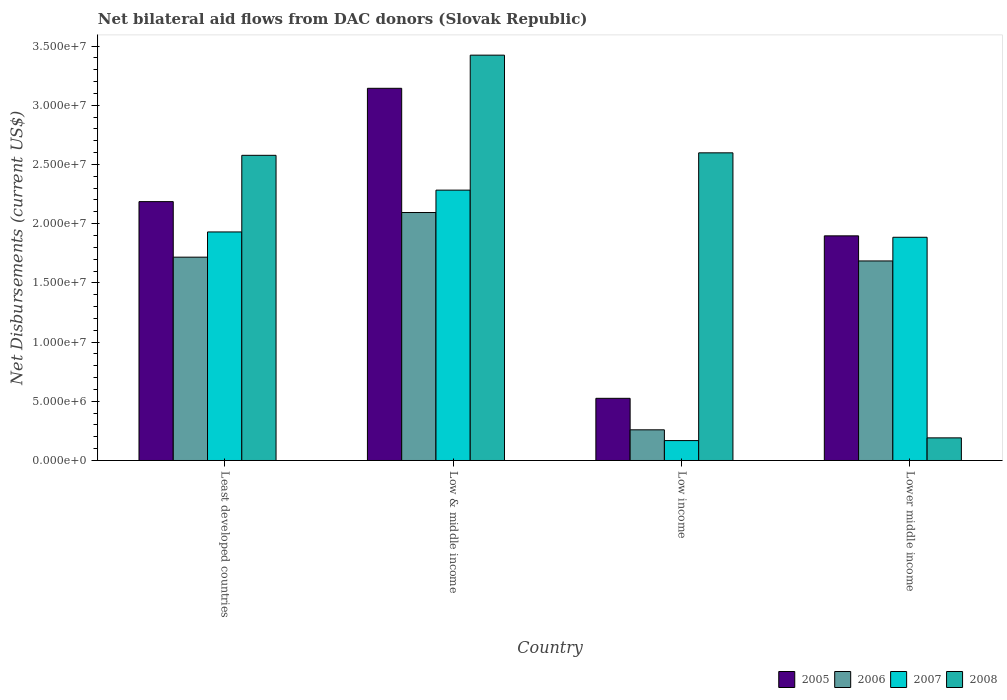How many different coloured bars are there?
Your response must be concise. 4. How many groups of bars are there?
Provide a succinct answer. 4. Are the number of bars per tick equal to the number of legend labels?
Make the answer very short. Yes. Are the number of bars on each tick of the X-axis equal?
Offer a terse response. Yes. How many bars are there on the 1st tick from the right?
Give a very brief answer. 4. What is the label of the 4th group of bars from the left?
Your response must be concise. Lower middle income. What is the net bilateral aid flows in 2006 in Low income?
Your answer should be compact. 2.59e+06. Across all countries, what is the maximum net bilateral aid flows in 2008?
Offer a terse response. 3.42e+07. Across all countries, what is the minimum net bilateral aid flows in 2005?
Provide a succinct answer. 5.25e+06. In which country was the net bilateral aid flows in 2007 maximum?
Your response must be concise. Low & middle income. What is the total net bilateral aid flows in 2007 in the graph?
Keep it short and to the point. 6.27e+07. What is the difference between the net bilateral aid flows in 2005 in Least developed countries and that in Lower middle income?
Provide a short and direct response. 2.89e+06. What is the difference between the net bilateral aid flows in 2005 in Lower middle income and the net bilateral aid flows in 2007 in Low & middle income?
Provide a succinct answer. -3.86e+06. What is the average net bilateral aid flows in 2006 per country?
Ensure brevity in your answer.  1.44e+07. What is the difference between the net bilateral aid flows of/in 2008 and net bilateral aid flows of/in 2006 in Lower middle income?
Give a very brief answer. -1.49e+07. What is the ratio of the net bilateral aid flows in 2007 in Least developed countries to that in Low & middle income?
Make the answer very short. 0.85. What is the difference between the highest and the second highest net bilateral aid flows in 2007?
Keep it short and to the point. 3.53e+06. What is the difference between the highest and the lowest net bilateral aid flows in 2006?
Keep it short and to the point. 1.84e+07. Is the sum of the net bilateral aid flows in 2007 in Low income and Lower middle income greater than the maximum net bilateral aid flows in 2006 across all countries?
Offer a terse response. No. What does the 1st bar from the left in Low & middle income represents?
Your answer should be very brief. 2005. What does the 1st bar from the right in Low income represents?
Offer a very short reply. 2008. Is it the case that in every country, the sum of the net bilateral aid flows in 2007 and net bilateral aid flows in 2006 is greater than the net bilateral aid flows in 2005?
Your response must be concise. No. How many bars are there?
Your answer should be compact. 16. Are all the bars in the graph horizontal?
Provide a short and direct response. No. What is the difference between two consecutive major ticks on the Y-axis?
Your answer should be very brief. 5.00e+06. Are the values on the major ticks of Y-axis written in scientific E-notation?
Your answer should be very brief. Yes. Does the graph contain any zero values?
Provide a short and direct response. No. Where does the legend appear in the graph?
Offer a very short reply. Bottom right. What is the title of the graph?
Offer a terse response. Net bilateral aid flows from DAC donors (Slovak Republic). Does "2008" appear as one of the legend labels in the graph?
Provide a succinct answer. Yes. What is the label or title of the Y-axis?
Keep it short and to the point. Net Disbursements (current US$). What is the Net Disbursements (current US$) in 2005 in Least developed countries?
Offer a terse response. 2.19e+07. What is the Net Disbursements (current US$) of 2006 in Least developed countries?
Offer a very short reply. 1.72e+07. What is the Net Disbursements (current US$) of 2007 in Least developed countries?
Your answer should be compact. 1.93e+07. What is the Net Disbursements (current US$) of 2008 in Least developed countries?
Provide a succinct answer. 2.58e+07. What is the Net Disbursements (current US$) in 2005 in Low & middle income?
Your answer should be compact. 3.14e+07. What is the Net Disbursements (current US$) in 2006 in Low & middle income?
Your response must be concise. 2.09e+07. What is the Net Disbursements (current US$) of 2007 in Low & middle income?
Provide a short and direct response. 2.28e+07. What is the Net Disbursements (current US$) in 2008 in Low & middle income?
Provide a short and direct response. 3.42e+07. What is the Net Disbursements (current US$) of 2005 in Low income?
Your answer should be very brief. 5.25e+06. What is the Net Disbursements (current US$) of 2006 in Low income?
Offer a very short reply. 2.59e+06. What is the Net Disbursements (current US$) in 2007 in Low income?
Your answer should be very brief. 1.68e+06. What is the Net Disbursements (current US$) in 2008 in Low income?
Your answer should be compact. 2.60e+07. What is the Net Disbursements (current US$) in 2005 in Lower middle income?
Your answer should be very brief. 1.90e+07. What is the Net Disbursements (current US$) in 2006 in Lower middle income?
Your answer should be compact. 1.68e+07. What is the Net Disbursements (current US$) in 2007 in Lower middle income?
Offer a very short reply. 1.88e+07. What is the Net Disbursements (current US$) in 2008 in Lower middle income?
Your answer should be very brief. 1.91e+06. Across all countries, what is the maximum Net Disbursements (current US$) of 2005?
Your answer should be compact. 3.14e+07. Across all countries, what is the maximum Net Disbursements (current US$) of 2006?
Keep it short and to the point. 2.09e+07. Across all countries, what is the maximum Net Disbursements (current US$) in 2007?
Make the answer very short. 2.28e+07. Across all countries, what is the maximum Net Disbursements (current US$) of 2008?
Provide a short and direct response. 3.42e+07. Across all countries, what is the minimum Net Disbursements (current US$) of 2005?
Keep it short and to the point. 5.25e+06. Across all countries, what is the minimum Net Disbursements (current US$) of 2006?
Provide a succinct answer. 2.59e+06. Across all countries, what is the minimum Net Disbursements (current US$) of 2007?
Your answer should be very brief. 1.68e+06. Across all countries, what is the minimum Net Disbursements (current US$) of 2008?
Make the answer very short. 1.91e+06. What is the total Net Disbursements (current US$) in 2005 in the graph?
Your answer should be very brief. 7.75e+07. What is the total Net Disbursements (current US$) of 2006 in the graph?
Your response must be concise. 5.76e+07. What is the total Net Disbursements (current US$) in 2007 in the graph?
Keep it short and to the point. 6.27e+07. What is the total Net Disbursements (current US$) of 2008 in the graph?
Keep it short and to the point. 8.79e+07. What is the difference between the Net Disbursements (current US$) of 2005 in Least developed countries and that in Low & middle income?
Provide a short and direct response. -9.57e+06. What is the difference between the Net Disbursements (current US$) in 2006 in Least developed countries and that in Low & middle income?
Give a very brief answer. -3.77e+06. What is the difference between the Net Disbursements (current US$) in 2007 in Least developed countries and that in Low & middle income?
Ensure brevity in your answer.  -3.53e+06. What is the difference between the Net Disbursements (current US$) of 2008 in Least developed countries and that in Low & middle income?
Provide a succinct answer. -8.46e+06. What is the difference between the Net Disbursements (current US$) of 2005 in Least developed countries and that in Low income?
Give a very brief answer. 1.66e+07. What is the difference between the Net Disbursements (current US$) of 2006 in Least developed countries and that in Low income?
Ensure brevity in your answer.  1.46e+07. What is the difference between the Net Disbursements (current US$) in 2007 in Least developed countries and that in Low income?
Offer a terse response. 1.76e+07. What is the difference between the Net Disbursements (current US$) in 2005 in Least developed countries and that in Lower middle income?
Provide a succinct answer. 2.89e+06. What is the difference between the Net Disbursements (current US$) of 2008 in Least developed countries and that in Lower middle income?
Your answer should be very brief. 2.39e+07. What is the difference between the Net Disbursements (current US$) in 2005 in Low & middle income and that in Low income?
Give a very brief answer. 2.62e+07. What is the difference between the Net Disbursements (current US$) of 2006 in Low & middle income and that in Low income?
Offer a very short reply. 1.84e+07. What is the difference between the Net Disbursements (current US$) in 2007 in Low & middle income and that in Low income?
Keep it short and to the point. 2.12e+07. What is the difference between the Net Disbursements (current US$) in 2008 in Low & middle income and that in Low income?
Your response must be concise. 8.25e+06. What is the difference between the Net Disbursements (current US$) in 2005 in Low & middle income and that in Lower middle income?
Offer a very short reply. 1.25e+07. What is the difference between the Net Disbursements (current US$) of 2006 in Low & middle income and that in Lower middle income?
Offer a terse response. 4.09e+06. What is the difference between the Net Disbursements (current US$) in 2007 in Low & middle income and that in Lower middle income?
Provide a short and direct response. 3.98e+06. What is the difference between the Net Disbursements (current US$) in 2008 in Low & middle income and that in Lower middle income?
Provide a succinct answer. 3.23e+07. What is the difference between the Net Disbursements (current US$) of 2005 in Low income and that in Lower middle income?
Give a very brief answer. -1.37e+07. What is the difference between the Net Disbursements (current US$) in 2006 in Low income and that in Lower middle income?
Offer a very short reply. -1.43e+07. What is the difference between the Net Disbursements (current US$) of 2007 in Low income and that in Lower middle income?
Offer a very short reply. -1.72e+07. What is the difference between the Net Disbursements (current US$) in 2008 in Low income and that in Lower middle income?
Keep it short and to the point. 2.41e+07. What is the difference between the Net Disbursements (current US$) in 2005 in Least developed countries and the Net Disbursements (current US$) in 2006 in Low & middle income?
Keep it short and to the point. 9.20e+05. What is the difference between the Net Disbursements (current US$) in 2005 in Least developed countries and the Net Disbursements (current US$) in 2007 in Low & middle income?
Ensure brevity in your answer.  -9.70e+05. What is the difference between the Net Disbursements (current US$) in 2005 in Least developed countries and the Net Disbursements (current US$) in 2008 in Low & middle income?
Ensure brevity in your answer.  -1.24e+07. What is the difference between the Net Disbursements (current US$) of 2006 in Least developed countries and the Net Disbursements (current US$) of 2007 in Low & middle income?
Your response must be concise. -5.66e+06. What is the difference between the Net Disbursements (current US$) of 2006 in Least developed countries and the Net Disbursements (current US$) of 2008 in Low & middle income?
Your answer should be compact. -1.71e+07. What is the difference between the Net Disbursements (current US$) of 2007 in Least developed countries and the Net Disbursements (current US$) of 2008 in Low & middle income?
Keep it short and to the point. -1.49e+07. What is the difference between the Net Disbursements (current US$) in 2005 in Least developed countries and the Net Disbursements (current US$) in 2006 in Low income?
Offer a terse response. 1.93e+07. What is the difference between the Net Disbursements (current US$) in 2005 in Least developed countries and the Net Disbursements (current US$) in 2007 in Low income?
Your response must be concise. 2.02e+07. What is the difference between the Net Disbursements (current US$) of 2005 in Least developed countries and the Net Disbursements (current US$) of 2008 in Low income?
Ensure brevity in your answer.  -4.12e+06. What is the difference between the Net Disbursements (current US$) of 2006 in Least developed countries and the Net Disbursements (current US$) of 2007 in Low income?
Give a very brief answer. 1.55e+07. What is the difference between the Net Disbursements (current US$) in 2006 in Least developed countries and the Net Disbursements (current US$) in 2008 in Low income?
Ensure brevity in your answer.  -8.81e+06. What is the difference between the Net Disbursements (current US$) of 2007 in Least developed countries and the Net Disbursements (current US$) of 2008 in Low income?
Provide a succinct answer. -6.68e+06. What is the difference between the Net Disbursements (current US$) of 2005 in Least developed countries and the Net Disbursements (current US$) of 2006 in Lower middle income?
Provide a succinct answer. 5.01e+06. What is the difference between the Net Disbursements (current US$) in 2005 in Least developed countries and the Net Disbursements (current US$) in 2007 in Lower middle income?
Give a very brief answer. 3.01e+06. What is the difference between the Net Disbursements (current US$) in 2005 in Least developed countries and the Net Disbursements (current US$) in 2008 in Lower middle income?
Offer a terse response. 2.00e+07. What is the difference between the Net Disbursements (current US$) in 2006 in Least developed countries and the Net Disbursements (current US$) in 2007 in Lower middle income?
Your response must be concise. -1.68e+06. What is the difference between the Net Disbursements (current US$) of 2006 in Least developed countries and the Net Disbursements (current US$) of 2008 in Lower middle income?
Your answer should be compact. 1.53e+07. What is the difference between the Net Disbursements (current US$) of 2007 in Least developed countries and the Net Disbursements (current US$) of 2008 in Lower middle income?
Your answer should be compact. 1.74e+07. What is the difference between the Net Disbursements (current US$) of 2005 in Low & middle income and the Net Disbursements (current US$) of 2006 in Low income?
Offer a very short reply. 2.88e+07. What is the difference between the Net Disbursements (current US$) in 2005 in Low & middle income and the Net Disbursements (current US$) in 2007 in Low income?
Offer a terse response. 2.98e+07. What is the difference between the Net Disbursements (current US$) of 2005 in Low & middle income and the Net Disbursements (current US$) of 2008 in Low income?
Offer a very short reply. 5.45e+06. What is the difference between the Net Disbursements (current US$) of 2006 in Low & middle income and the Net Disbursements (current US$) of 2007 in Low income?
Offer a very short reply. 1.93e+07. What is the difference between the Net Disbursements (current US$) in 2006 in Low & middle income and the Net Disbursements (current US$) in 2008 in Low income?
Provide a succinct answer. -5.04e+06. What is the difference between the Net Disbursements (current US$) of 2007 in Low & middle income and the Net Disbursements (current US$) of 2008 in Low income?
Provide a succinct answer. -3.15e+06. What is the difference between the Net Disbursements (current US$) in 2005 in Low & middle income and the Net Disbursements (current US$) in 2006 in Lower middle income?
Your answer should be very brief. 1.46e+07. What is the difference between the Net Disbursements (current US$) of 2005 in Low & middle income and the Net Disbursements (current US$) of 2007 in Lower middle income?
Your answer should be compact. 1.26e+07. What is the difference between the Net Disbursements (current US$) in 2005 in Low & middle income and the Net Disbursements (current US$) in 2008 in Lower middle income?
Make the answer very short. 2.95e+07. What is the difference between the Net Disbursements (current US$) of 2006 in Low & middle income and the Net Disbursements (current US$) of 2007 in Lower middle income?
Provide a short and direct response. 2.09e+06. What is the difference between the Net Disbursements (current US$) in 2006 in Low & middle income and the Net Disbursements (current US$) in 2008 in Lower middle income?
Make the answer very short. 1.90e+07. What is the difference between the Net Disbursements (current US$) of 2007 in Low & middle income and the Net Disbursements (current US$) of 2008 in Lower middle income?
Offer a terse response. 2.09e+07. What is the difference between the Net Disbursements (current US$) of 2005 in Low income and the Net Disbursements (current US$) of 2006 in Lower middle income?
Your answer should be compact. -1.16e+07. What is the difference between the Net Disbursements (current US$) in 2005 in Low income and the Net Disbursements (current US$) in 2007 in Lower middle income?
Offer a terse response. -1.36e+07. What is the difference between the Net Disbursements (current US$) in 2005 in Low income and the Net Disbursements (current US$) in 2008 in Lower middle income?
Offer a terse response. 3.34e+06. What is the difference between the Net Disbursements (current US$) of 2006 in Low income and the Net Disbursements (current US$) of 2007 in Lower middle income?
Make the answer very short. -1.63e+07. What is the difference between the Net Disbursements (current US$) in 2006 in Low income and the Net Disbursements (current US$) in 2008 in Lower middle income?
Offer a terse response. 6.80e+05. What is the difference between the Net Disbursements (current US$) of 2007 in Low income and the Net Disbursements (current US$) of 2008 in Lower middle income?
Ensure brevity in your answer.  -2.30e+05. What is the average Net Disbursements (current US$) in 2005 per country?
Keep it short and to the point. 1.94e+07. What is the average Net Disbursements (current US$) in 2006 per country?
Offer a very short reply. 1.44e+07. What is the average Net Disbursements (current US$) of 2007 per country?
Provide a short and direct response. 1.57e+07. What is the average Net Disbursements (current US$) in 2008 per country?
Keep it short and to the point. 2.20e+07. What is the difference between the Net Disbursements (current US$) in 2005 and Net Disbursements (current US$) in 2006 in Least developed countries?
Offer a very short reply. 4.69e+06. What is the difference between the Net Disbursements (current US$) of 2005 and Net Disbursements (current US$) of 2007 in Least developed countries?
Your answer should be very brief. 2.56e+06. What is the difference between the Net Disbursements (current US$) of 2005 and Net Disbursements (current US$) of 2008 in Least developed countries?
Provide a succinct answer. -3.91e+06. What is the difference between the Net Disbursements (current US$) in 2006 and Net Disbursements (current US$) in 2007 in Least developed countries?
Your answer should be compact. -2.13e+06. What is the difference between the Net Disbursements (current US$) of 2006 and Net Disbursements (current US$) of 2008 in Least developed countries?
Make the answer very short. -8.60e+06. What is the difference between the Net Disbursements (current US$) of 2007 and Net Disbursements (current US$) of 2008 in Least developed countries?
Offer a very short reply. -6.47e+06. What is the difference between the Net Disbursements (current US$) of 2005 and Net Disbursements (current US$) of 2006 in Low & middle income?
Offer a terse response. 1.05e+07. What is the difference between the Net Disbursements (current US$) of 2005 and Net Disbursements (current US$) of 2007 in Low & middle income?
Offer a terse response. 8.60e+06. What is the difference between the Net Disbursements (current US$) in 2005 and Net Disbursements (current US$) in 2008 in Low & middle income?
Offer a terse response. -2.80e+06. What is the difference between the Net Disbursements (current US$) of 2006 and Net Disbursements (current US$) of 2007 in Low & middle income?
Provide a short and direct response. -1.89e+06. What is the difference between the Net Disbursements (current US$) of 2006 and Net Disbursements (current US$) of 2008 in Low & middle income?
Ensure brevity in your answer.  -1.33e+07. What is the difference between the Net Disbursements (current US$) in 2007 and Net Disbursements (current US$) in 2008 in Low & middle income?
Make the answer very short. -1.14e+07. What is the difference between the Net Disbursements (current US$) in 2005 and Net Disbursements (current US$) in 2006 in Low income?
Offer a very short reply. 2.66e+06. What is the difference between the Net Disbursements (current US$) of 2005 and Net Disbursements (current US$) of 2007 in Low income?
Your answer should be very brief. 3.57e+06. What is the difference between the Net Disbursements (current US$) of 2005 and Net Disbursements (current US$) of 2008 in Low income?
Your response must be concise. -2.07e+07. What is the difference between the Net Disbursements (current US$) of 2006 and Net Disbursements (current US$) of 2007 in Low income?
Offer a very short reply. 9.10e+05. What is the difference between the Net Disbursements (current US$) of 2006 and Net Disbursements (current US$) of 2008 in Low income?
Provide a succinct answer. -2.34e+07. What is the difference between the Net Disbursements (current US$) in 2007 and Net Disbursements (current US$) in 2008 in Low income?
Your response must be concise. -2.43e+07. What is the difference between the Net Disbursements (current US$) of 2005 and Net Disbursements (current US$) of 2006 in Lower middle income?
Your answer should be compact. 2.12e+06. What is the difference between the Net Disbursements (current US$) of 2005 and Net Disbursements (current US$) of 2007 in Lower middle income?
Make the answer very short. 1.20e+05. What is the difference between the Net Disbursements (current US$) of 2005 and Net Disbursements (current US$) of 2008 in Lower middle income?
Make the answer very short. 1.71e+07. What is the difference between the Net Disbursements (current US$) in 2006 and Net Disbursements (current US$) in 2008 in Lower middle income?
Provide a succinct answer. 1.49e+07. What is the difference between the Net Disbursements (current US$) in 2007 and Net Disbursements (current US$) in 2008 in Lower middle income?
Make the answer very short. 1.69e+07. What is the ratio of the Net Disbursements (current US$) in 2005 in Least developed countries to that in Low & middle income?
Offer a terse response. 0.7. What is the ratio of the Net Disbursements (current US$) of 2006 in Least developed countries to that in Low & middle income?
Offer a terse response. 0.82. What is the ratio of the Net Disbursements (current US$) in 2007 in Least developed countries to that in Low & middle income?
Make the answer very short. 0.85. What is the ratio of the Net Disbursements (current US$) in 2008 in Least developed countries to that in Low & middle income?
Your answer should be very brief. 0.75. What is the ratio of the Net Disbursements (current US$) of 2005 in Least developed countries to that in Low income?
Your answer should be very brief. 4.16. What is the ratio of the Net Disbursements (current US$) in 2006 in Least developed countries to that in Low income?
Your answer should be compact. 6.63. What is the ratio of the Net Disbursements (current US$) in 2007 in Least developed countries to that in Low income?
Provide a short and direct response. 11.49. What is the ratio of the Net Disbursements (current US$) of 2005 in Least developed countries to that in Lower middle income?
Make the answer very short. 1.15. What is the ratio of the Net Disbursements (current US$) in 2006 in Least developed countries to that in Lower middle income?
Your answer should be very brief. 1.02. What is the ratio of the Net Disbursements (current US$) in 2007 in Least developed countries to that in Lower middle income?
Offer a terse response. 1.02. What is the ratio of the Net Disbursements (current US$) of 2008 in Least developed countries to that in Lower middle income?
Offer a terse response. 13.49. What is the ratio of the Net Disbursements (current US$) in 2005 in Low & middle income to that in Low income?
Make the answer very short. 5.99. What is the ratio of the Net Disbursements (current US$) of 2006 in Low & middle income to that in Low income?
Your answer should be compact. 8.08. What is the ratio of the Net Disbursements (current US$) of 2007 in Low & middle income to that in Low income?
Make the answer very short. 13.59. What is the ratio of the Net Disbursements (current US$) of 2008 in Low & middle income to that in Low income?
Offer a very short reply. 1.32. What is the ratio of the Net Disbursements (current US$) in 2005 in Low & middle income to that in Lower middle income?
Your response must be concise. 1.66. What is the ratio of the Net Disbursements (current US$) of 2006 in Low & middle income to that in Lower middle income?
Make the answer very short. 1.24. What is the ratio of the Net Disbursements (current US$) of 2007 in Low & middle income to that in Lower middle income?
Provide a short and direct response. 1.21. What is the ratio of the Net Disbursements (current US$) in 2008 in Low & middle income to that in Lower middle income?
Provide a succinct answer. 17.92. What is the ratio of the Net Disbursements (current US$) of 2005 in Low income to that in Lower middle income?
Keep it short and to the point. 0.28. What is the ratio of the Net Disbursements (current US$) of 2006 in Low income to that in Lower middle income?
Offer a very short reply. 0.15. What is the ratio of the Net Disbursements (current US$) of 2007 in Low income to that in Lower middle income?
Offer a terse response. 0.09. What is the ratio of the Net Disbursements (current US$) in 2008 in Low income to that in Lower middle income?
Keep it short and to the point. 13.6. What is the difference between the highest and the second highest Net Disbursements (current US$) of 2005?
Your answer should be very brief. 9.57e+06. What is the difference between the highest and the second highest Net Disbursements (current US$) of 2006?
Offer a terse response. 3.77e+06. What is the difference between the highest and the second highest Net Disbursements (current US$) of 2007?
Give a very brief answer. 3.53e+06. What is the difference between the highest and the second highest Net Disbursements (current US$) of 2008?
Offer a very short reply. 8.25e+06. What is the difference between the highest and the lowest Net Disbursements (current US$) of 2005?
Keep it short and to the point. 2.62e+07. What is the difference between the highest and the lowest Net Disbursements (current US$) of 2006?
Your answer should be compact. 1.84e+07. What is the difference between the highest and the lowest Net Disbursements (current US$) of 2007?
Provide a short and direct response. 2.12e+07. What is the difference between the highest and the lowest Net Disbursements (current US$) in 2008?
Give a very brief answer. 3.23e+07. 